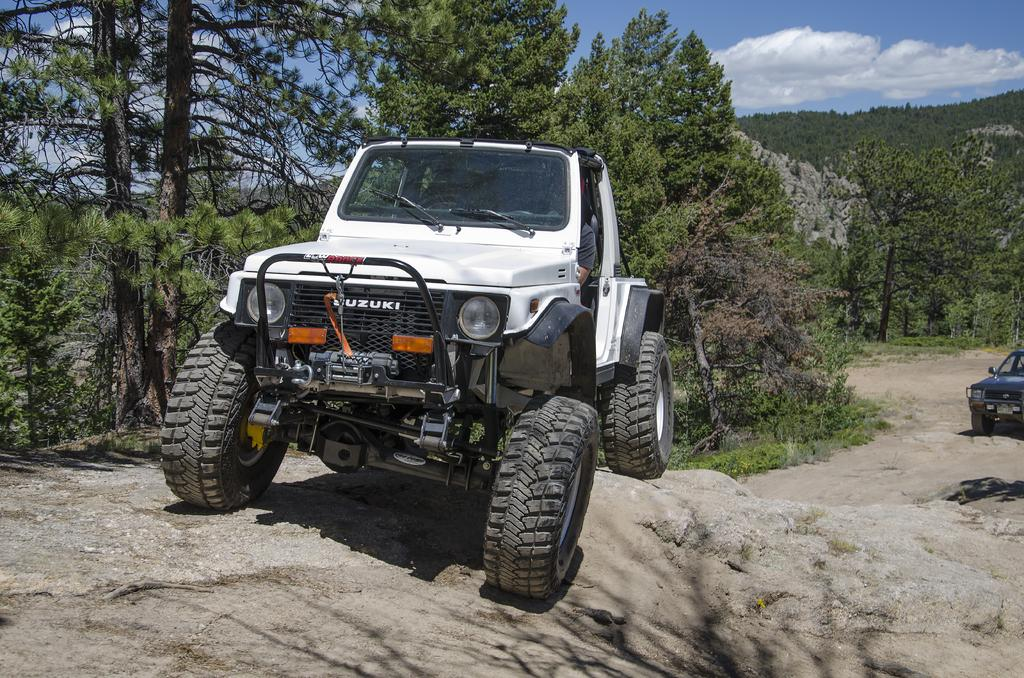What vehicle is on a rock in the image? There is a jeep on a rock in the image. What can be seen in the background of the image? There are trees in the background of the image. What is visible at the top of the image? The sky is visible at the top of the image. Are there any other vehicles in the image? Yes, there is another car on a rock on the right side of the image. What type of chairs can be seen floating in space in the image? There are no chairs or any reference to space in the image; it features a jeep and another car on rocks with trees and sky in the background. 